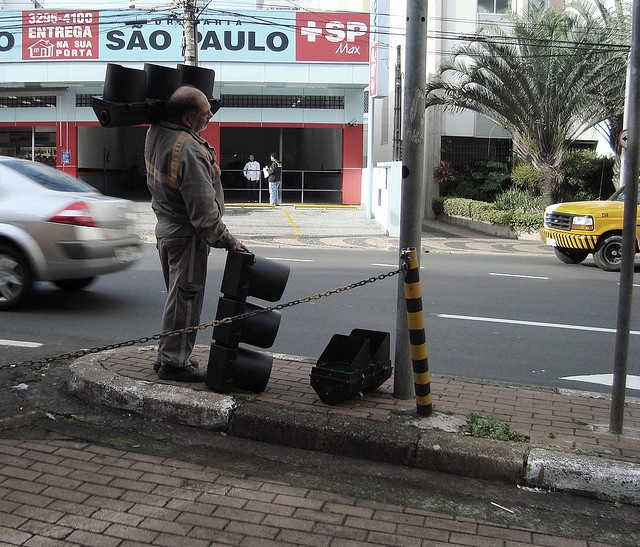Describe the objects in this image and their specific colors. I can see people in lightgray, black, gray, and darkgray tones, car in lightgray, gray, black, and darkgray tones, traffic light in lightgray, black, and gray tones, traffic light in lightgray, black, gray, darkgray, and white tones, and truck in lightgray, black, gray, khaki, and tan tones in this image. 